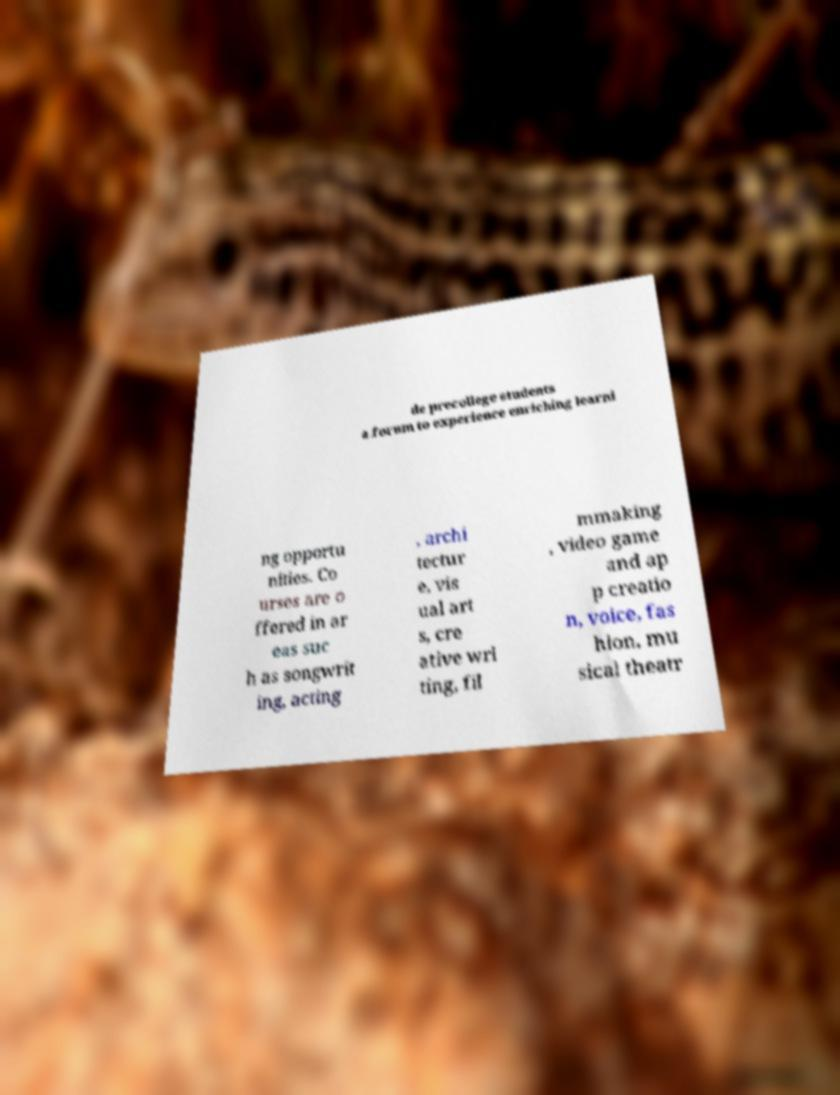Could you extract and type out the text from this image? de precollege students a forum to experience enriching learni ng opportu nities. Co urses are o ffered in ar eas suc h as songwrit ing, acting , archi tectur e, vis ual art s, cre ative wri ting, fil mmaking , video game and ap p creatio n, voice, fas hion, mu sical theatr 